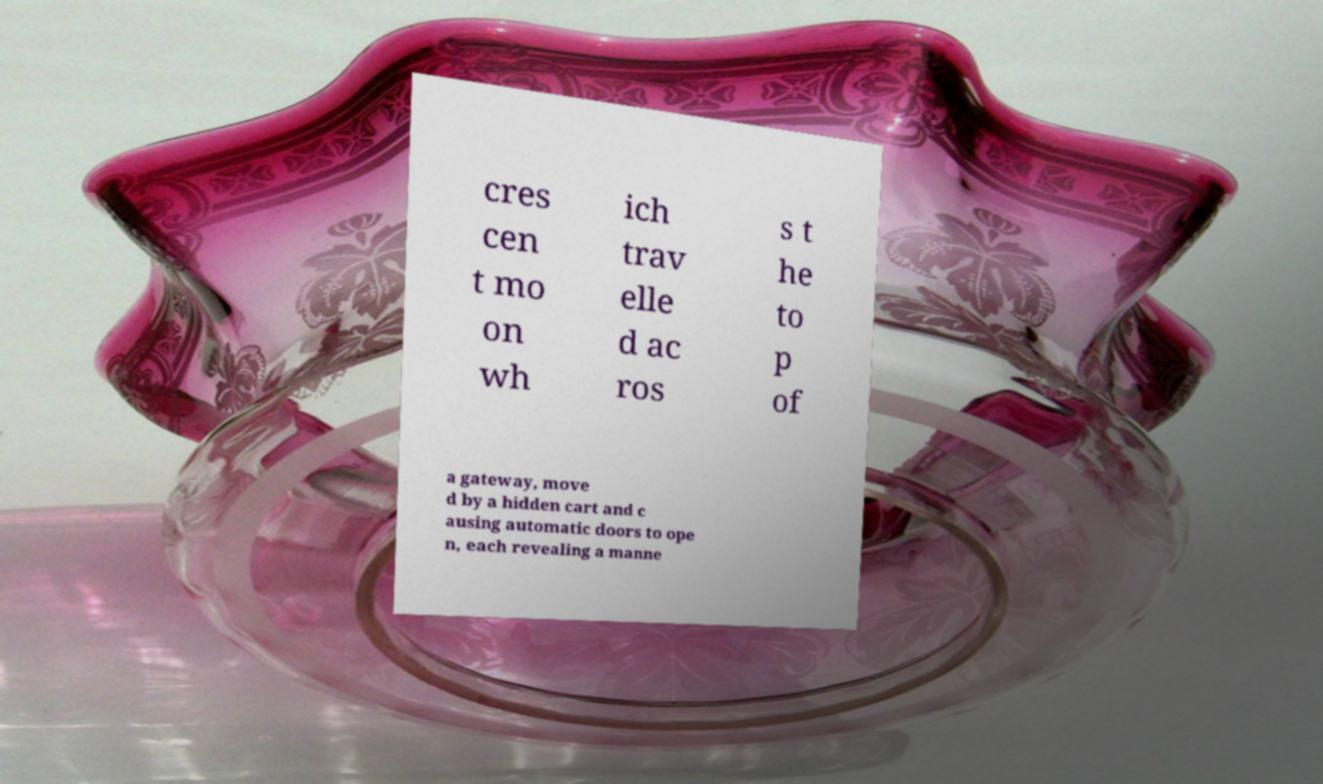Could you extract and type out the text from this image? cres cen t mo on wh ich trav elle d ac ros s t he to p of a gateway, move d by a hidden cart and c ausing automatic doors to ope n, each revealing a manne 